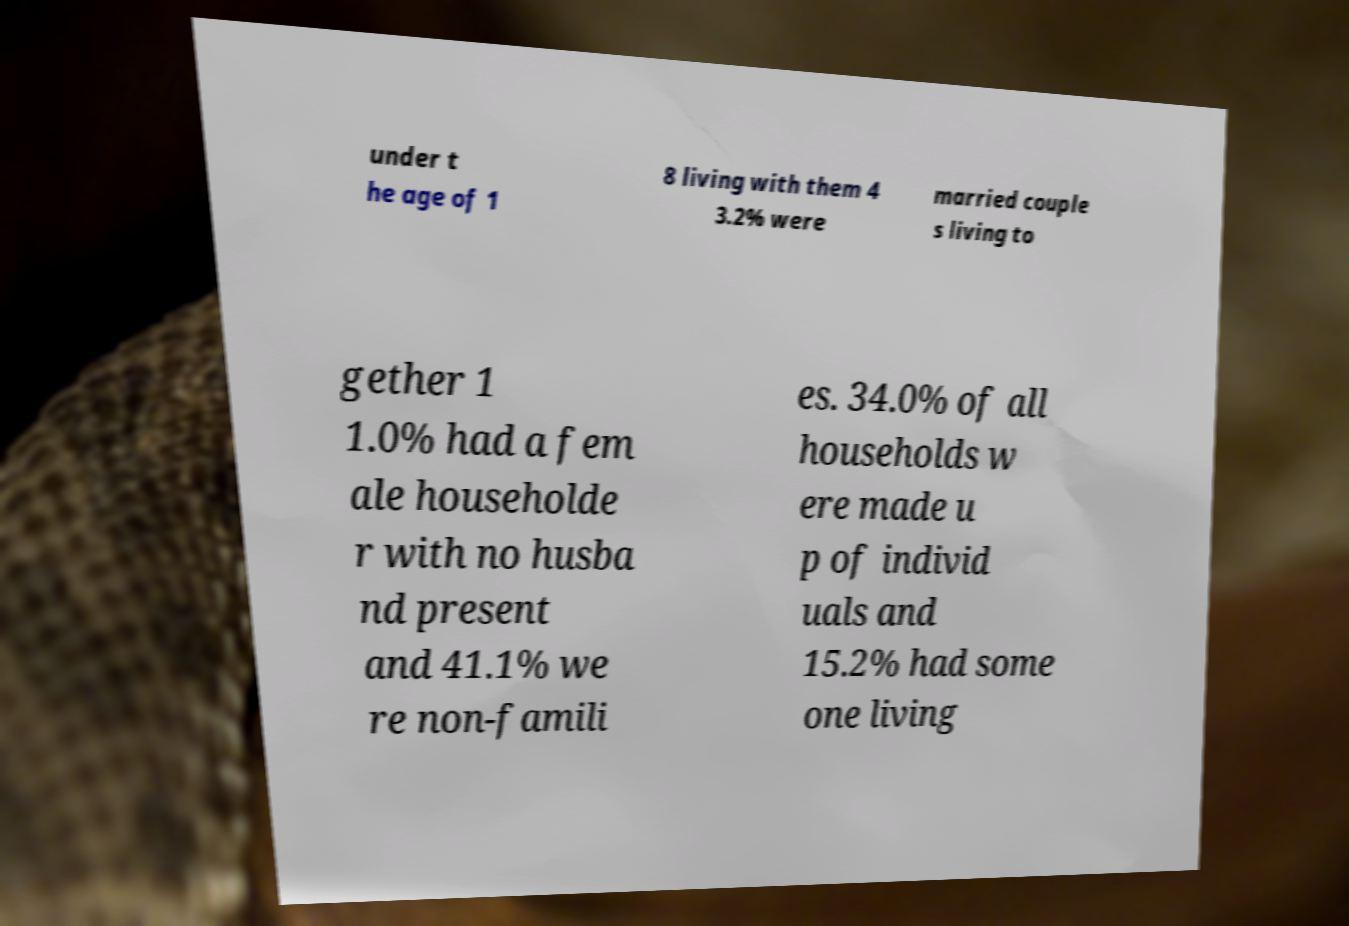Could you extract and type out the text from this image? under t he age of 1 8 living with them 4 3.2% were married couple s living to gether 1 1.0% had a fem ale householde r with no husba nd present and 41.1% we re non-famili es. 34.0% of all households w ere made u p of individ uals and 15.2% had some one living 